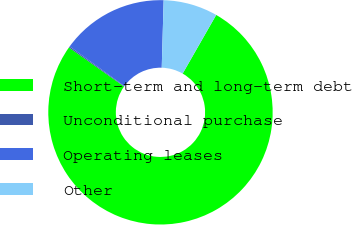<chart> <loc_0><loc_0><loc_500><loc_500><pie_chart><fcel>Short-term and long-term debt<fcel>Unconditional purchase<fcel>Operating leases<fcel>Other<nl><fcel>76.54%<fcel>0.18%<fcel>15.46%<fcel>7.82%<nl></chart> 